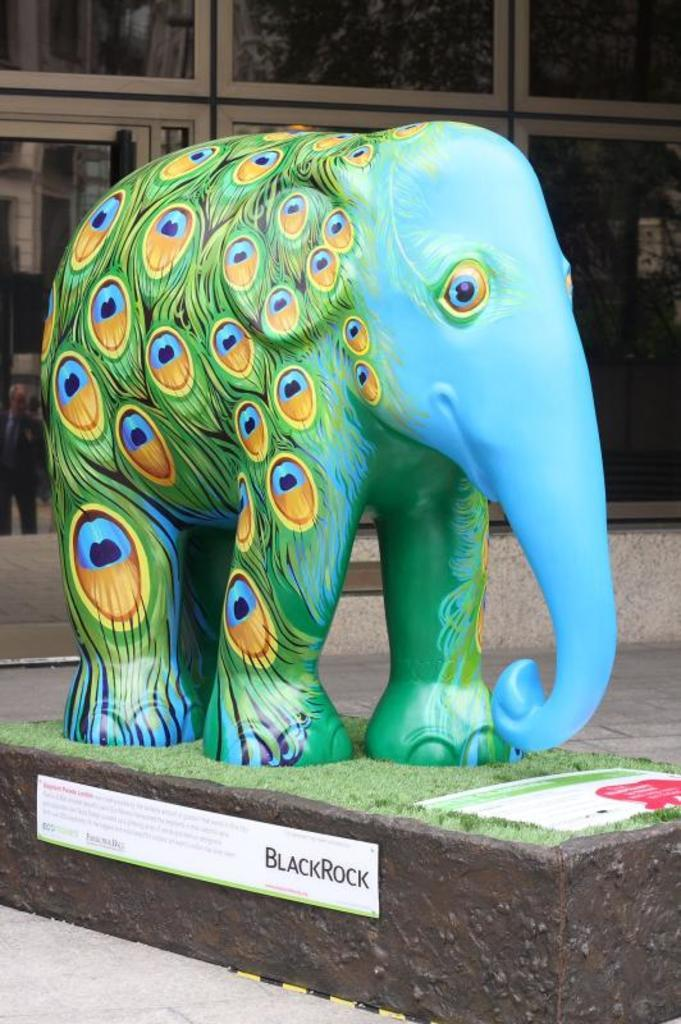What is the main subject in the foreground of the image? There is a sculpture of an elephant in the foreground of the image. What is located at the bottom of the image? There is a board at the bottom of the image. What type of architectural feature can be seen in the background of the image? There is a glass wall in the background of the image. How many drawers are visible in the image? There are no drawers present in the image. What type of fruit is hanging from the edge of the glass wall in the image? There is no fruit or edge of the glass wall visible in the image. 